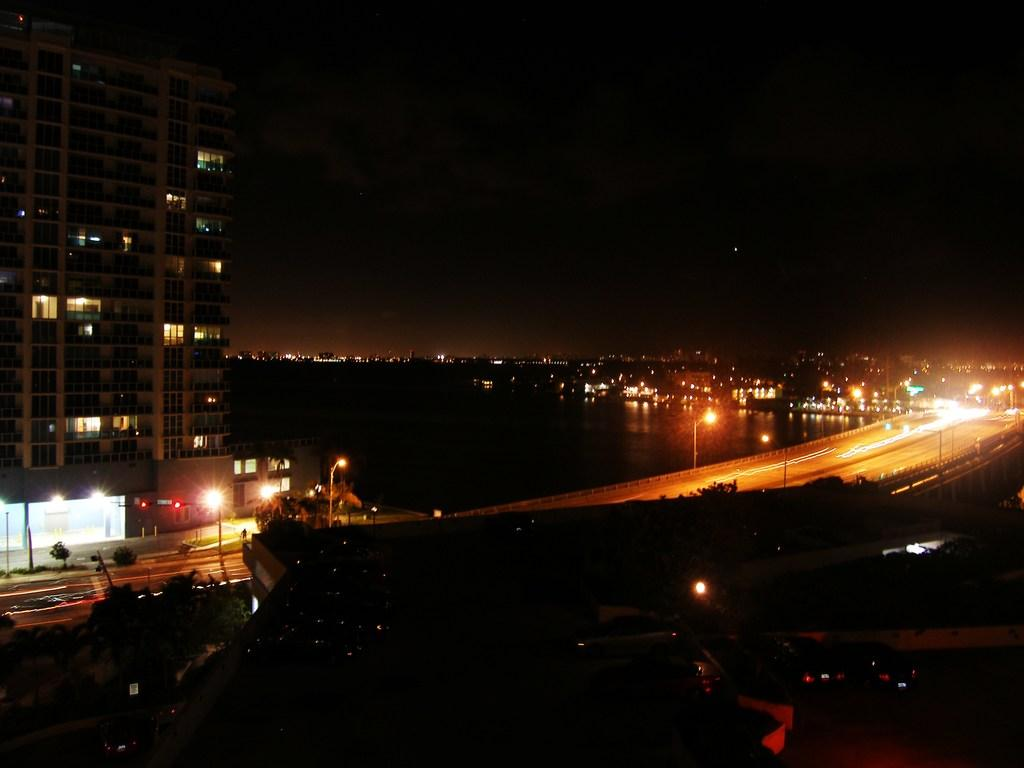What type of structures can be seen in the image? There are buildings in the image. What can be seen illuminating the area at night? Street lights are present in the image. What supports the street lights and other objects in the image? Street poles are visible in the image. What is the main pathway for transportation in the image? There is a road in the image. What natural elements are present in the image? Water, trees, and bushes are visible in the image. What type of vehicles can be seen on the road? Motor vehicles are in the image. How many kittens are playing on the beds in the image? There are no kittens or beds present in the image. What type of umbrella is being used to protect the trees from the rain? There is no umbrella present in the image, and the trees are not being protected from the rain. 